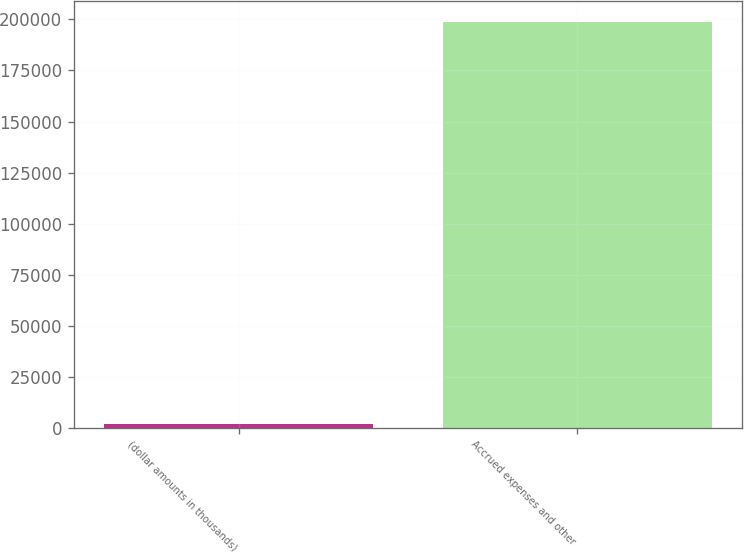Convert chart. <chart><loc_0><loc_0><loc_500><loc_500><bar_chart><fcel>(dollar amounts in thousands)<fcel>Accrued expenses and other<nl><fcel>2014<fcel>198947<nl></chart> 